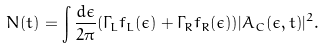Convert formula to latex. <formula><loc_0><loc_0><loc_500><loc_500>N ( t ) = \int \frac { d \epsilon } { 2 \pi } ( \Gamma _ { L } f _ { L } ( \epsilon ) + \Gamma _ { R } f _ { R } ( \epsilon ) ) | A _ { C } ( \epsilon , t ) | ^ { 2 } .</formula> 